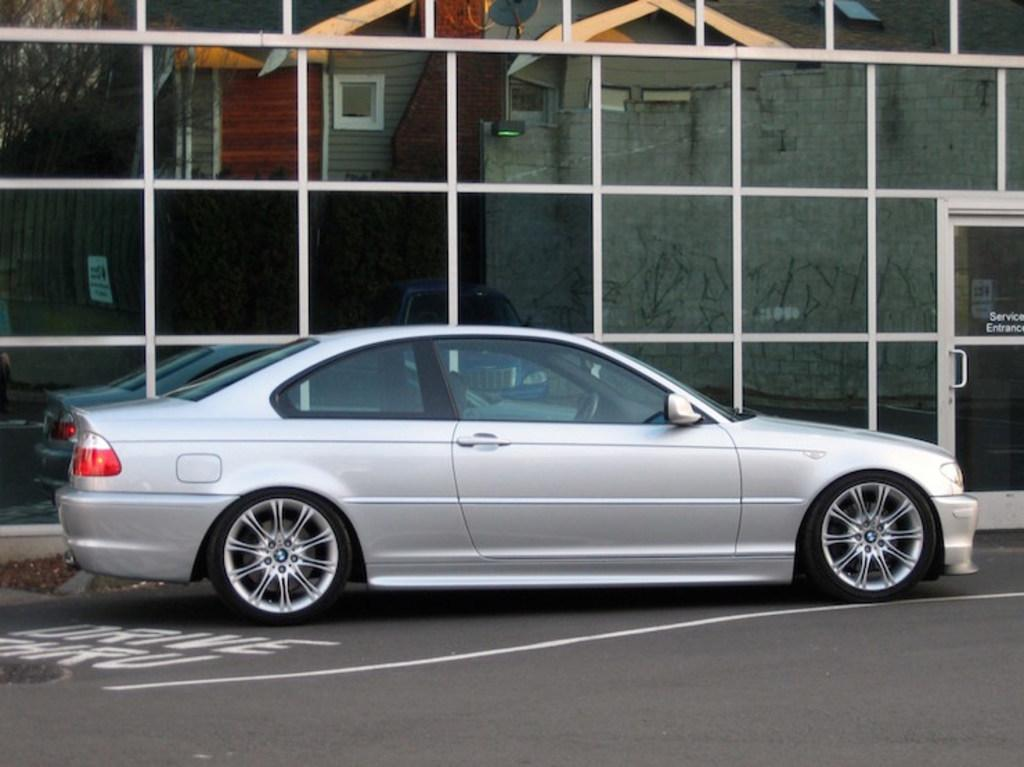What is the main subject of the image? There is a car on the road in the image. Can you describe any other objects or structures in the image? There is a door on the right side of the image. What is the glass wall reflecting in the image? The glass wall reflects the building, trees, wall, and other objects in the image. How many beans are visible on the car in the image? There are no beans visible on the car in the image. Is there a man standing next to the car in the image? There is no man standing next to the car in the image. 